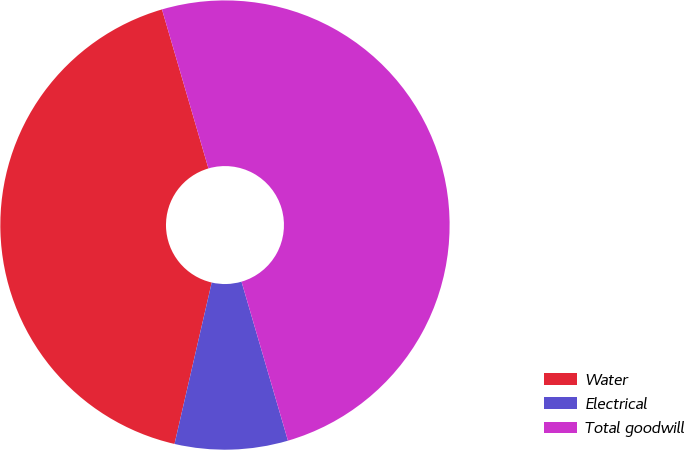Convert chart to OTSL. <chart><loc_0><loc_0><loc_500><loc_500><pie_chart><fcel>Water<fcel>Electrical<fcel>Total goodwill<nl><fcel>41.87%<fcel>8.13%<fcel>50.0%<nl></chart> 